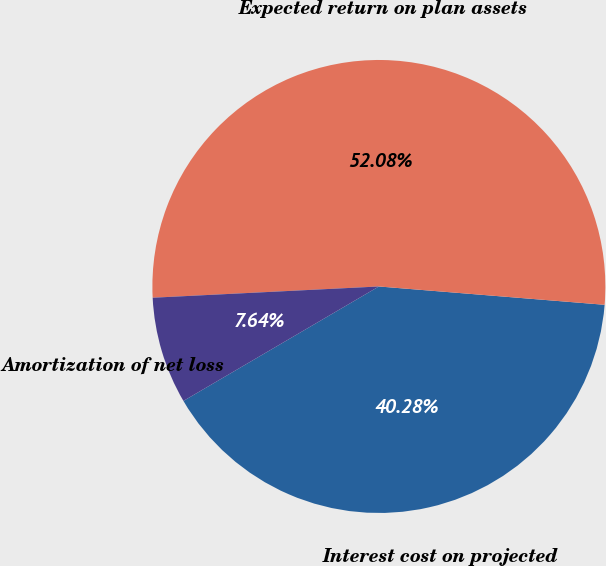<chart> <loc_0><loc_0><loc_500><loc_500><pie_chart><fcel>Interest cost on projected<fcel>Expected return on plan assets<fcel>Amortization of net loss<nl><fcel>40.28%<fcel>52.08%<fcel>7.64%<nl></chart> 